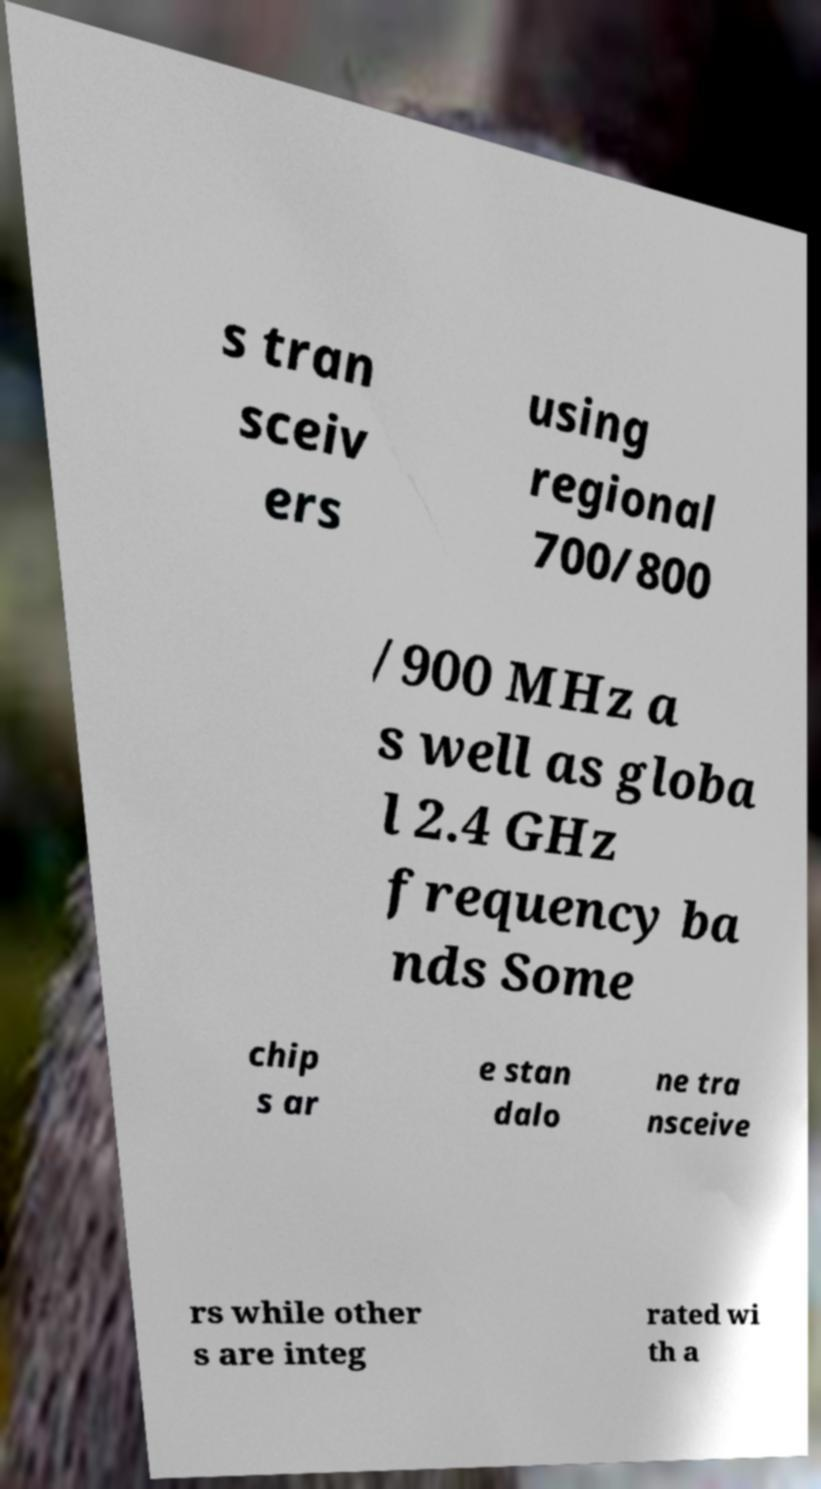Please identify and transcribe the text found in this image. s tran sceiv ers using regional 700/800 /900 MHz a s well as globa l 2.4 GHz frequency ba nds Some chip s ar e stan dalo ne tra nsceive rs while other s are integ rated wi th a 